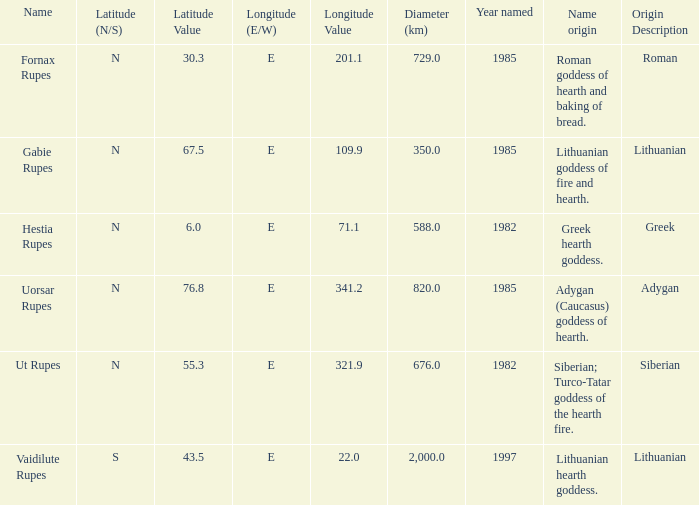How many features were discovered at a longitude of 109.9 degrees east? 1.0. 